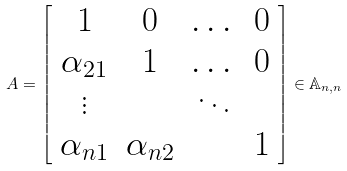Convert formula to latex. <formula><loc_0><loc_0><loc_500><loc_500>A = \left [ \begin{array} { c c c c } 1 & 0 & \dots & 0 \\ \alpha _ { 2 1 } & 1 & \dots & 0 \\ \vdots & & \ddots & \\ \alpha _ { n 1 } & \alpha _ { n 2 } & & 1 \end{array} \right ] \in \mathbb { A } _ { n , n }</formula> 